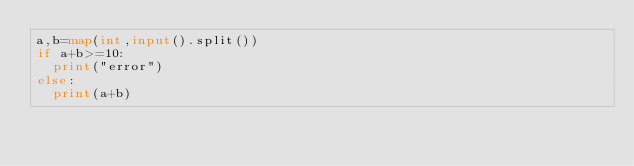Convert code to text. <code><loc_0><loc_0><loc_500><loc_500><_Python_>a,b=map(int,input().split())
if a+b>=10:
  print("error")
else:
  print(a+b)</code> 